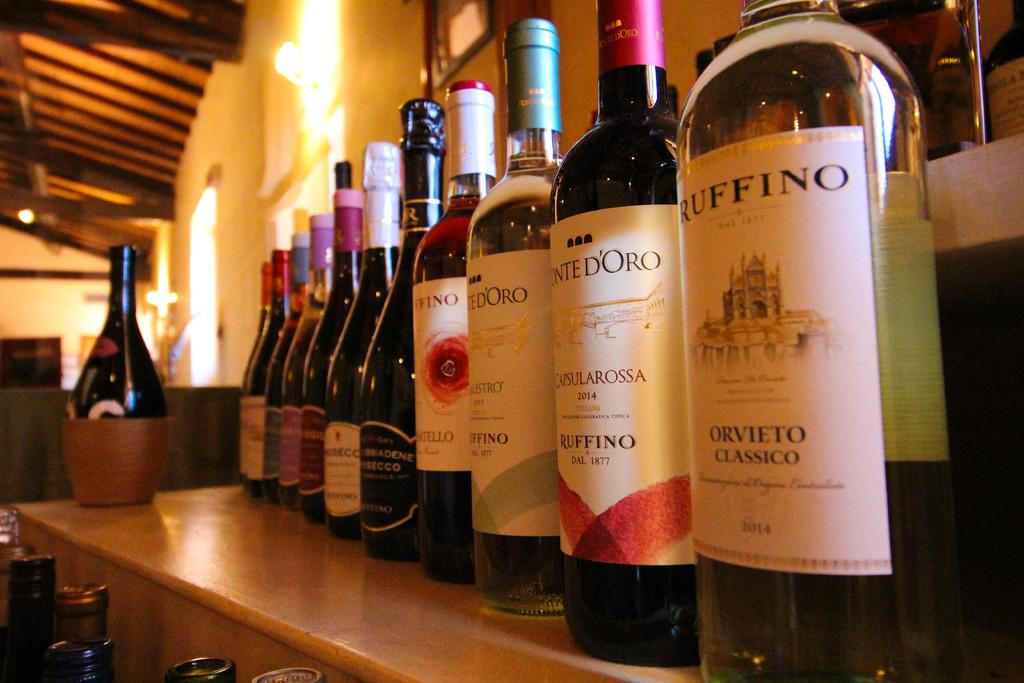<image>
Offer a succinct explanation of the picture presented. Bottles of Ruffino wine are lined up on a shelf. 